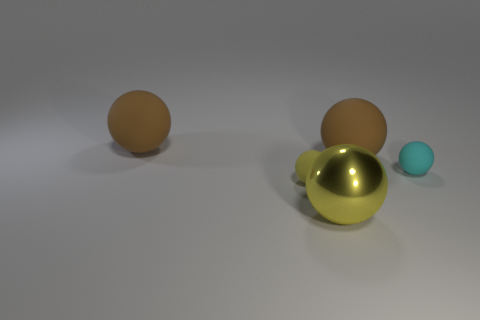Can you describe the arrangement and color contrast between the objects in the image? Certainly! The image depicts four objects with a noticeable gradient in size and color contrast. On the left, there are two brown spheres which may suggest a rubbery texture, followed by a large, reflective metallic gold sphere and a teal-colored smaller sphere on the right, providing a visual contrast between earthy and vibrant tones. 